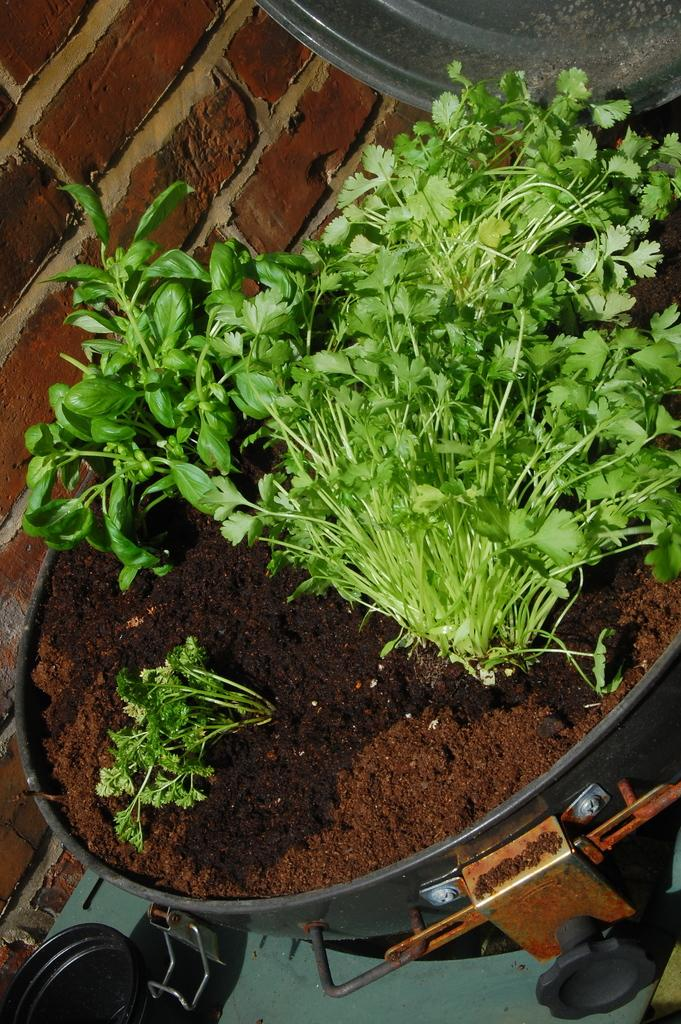What is the main object in the image? There is a pot in the image. What is inside the pot? There are: There are plants in the pot. What is used to support the plants in the pot? There is soil in the pot. What can be seen in the background of the image? There is a brick wall in the background of the image. Are there any other pots visible in the image? Yes, there is another pot at the left bottom of the image. What is the birth rate of the plants in the image? There is no information about the birth rate of the plants in the image, as this is not a relevant or observable detail. 